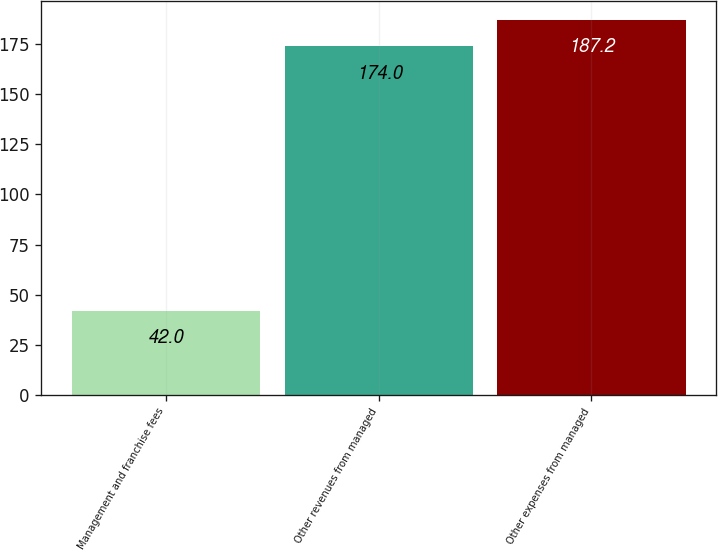<chart> <loc_0><loc_0><loc_500><loc_500><bar_chart><fcel>Management and franchise fees<fcel>Other revenues from managed<fcel>Other expenses from managed<nl><fcel>42<fcel>174<fcel>187.2<nl></chart> 